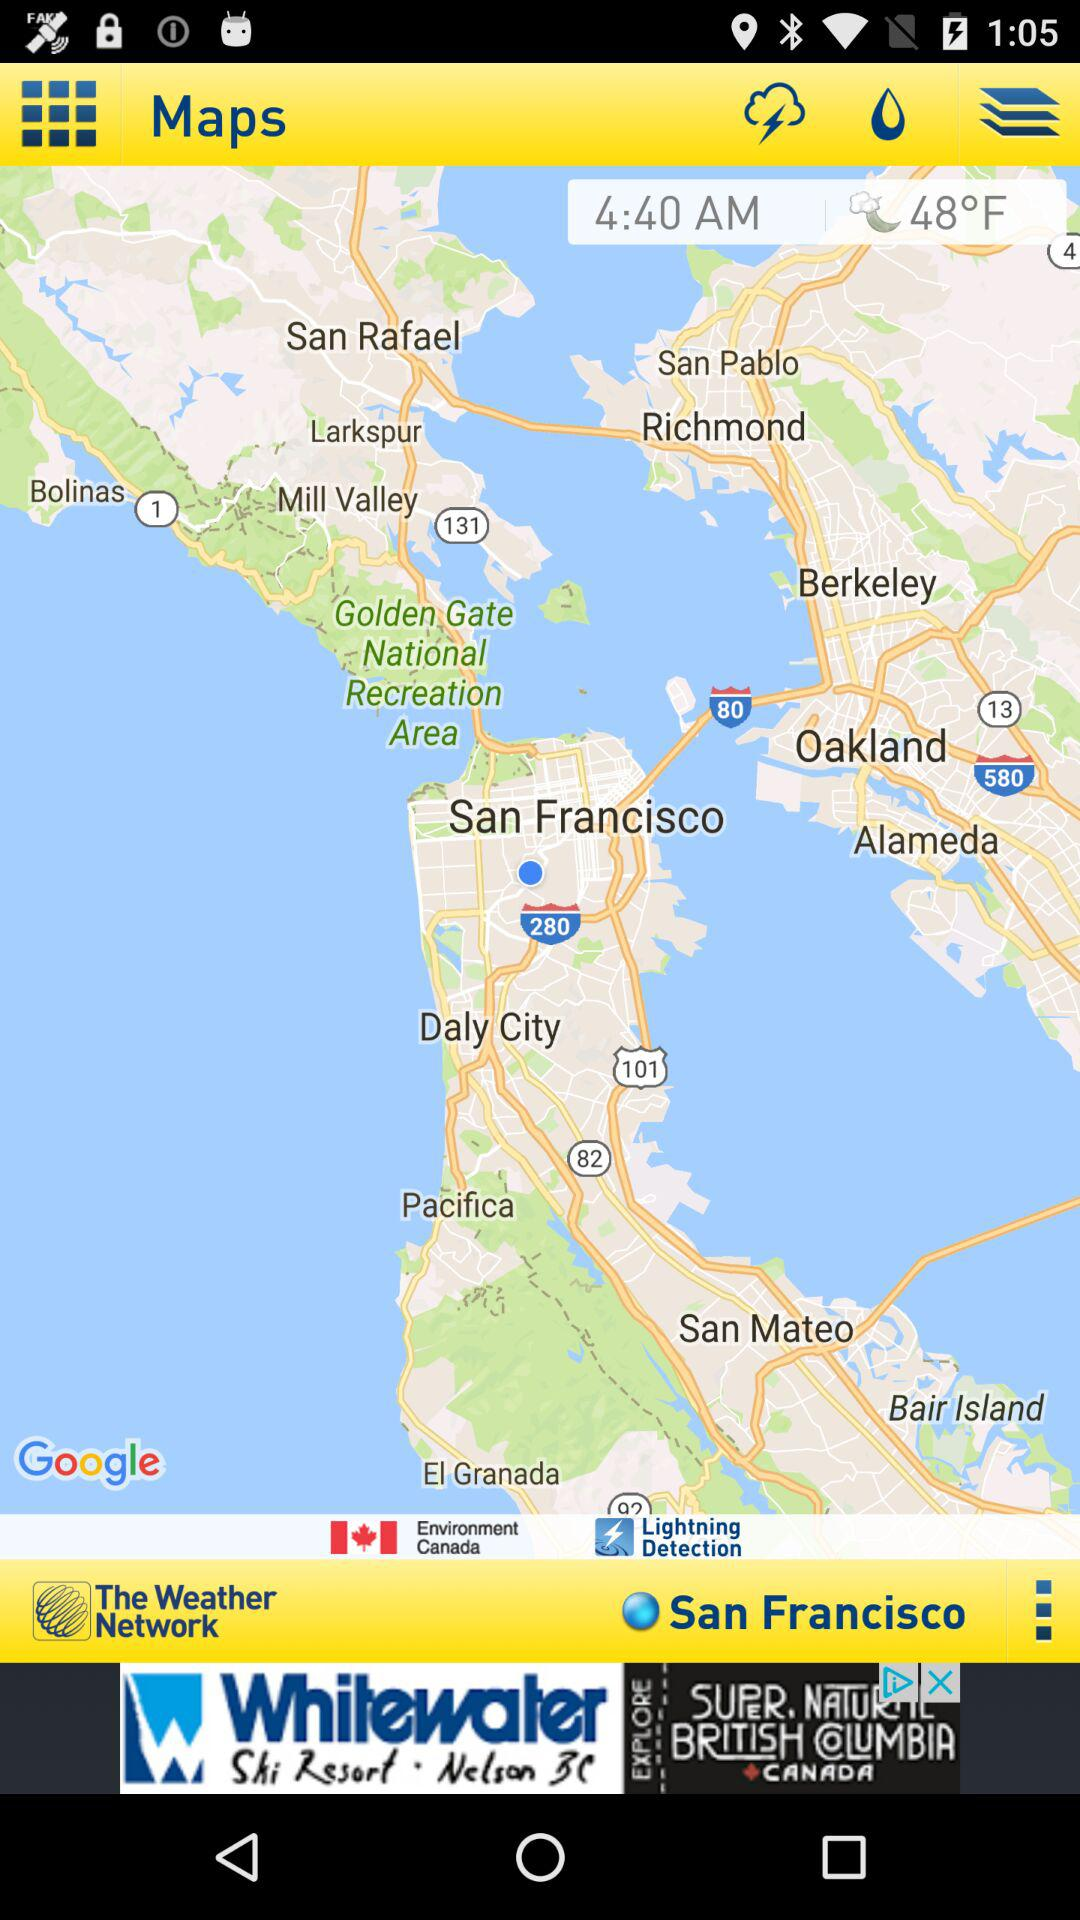What is the temperature shown on the screen? The shown temperature is 48°F. 